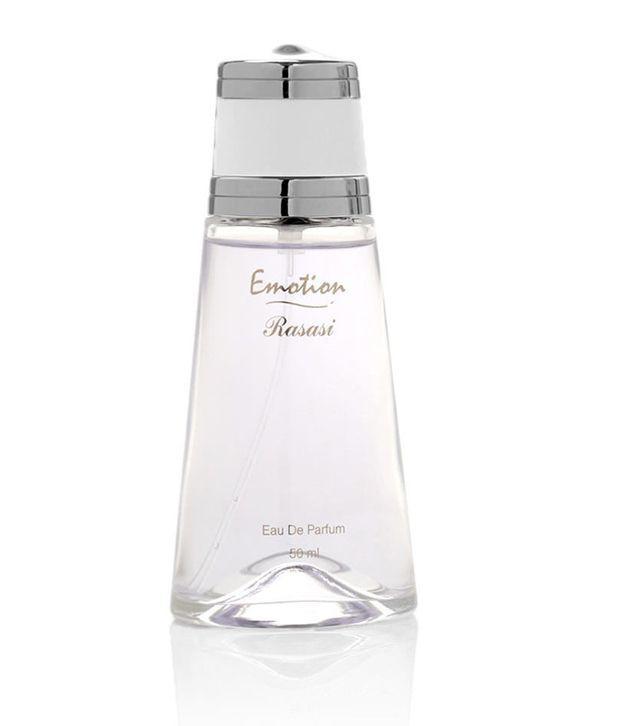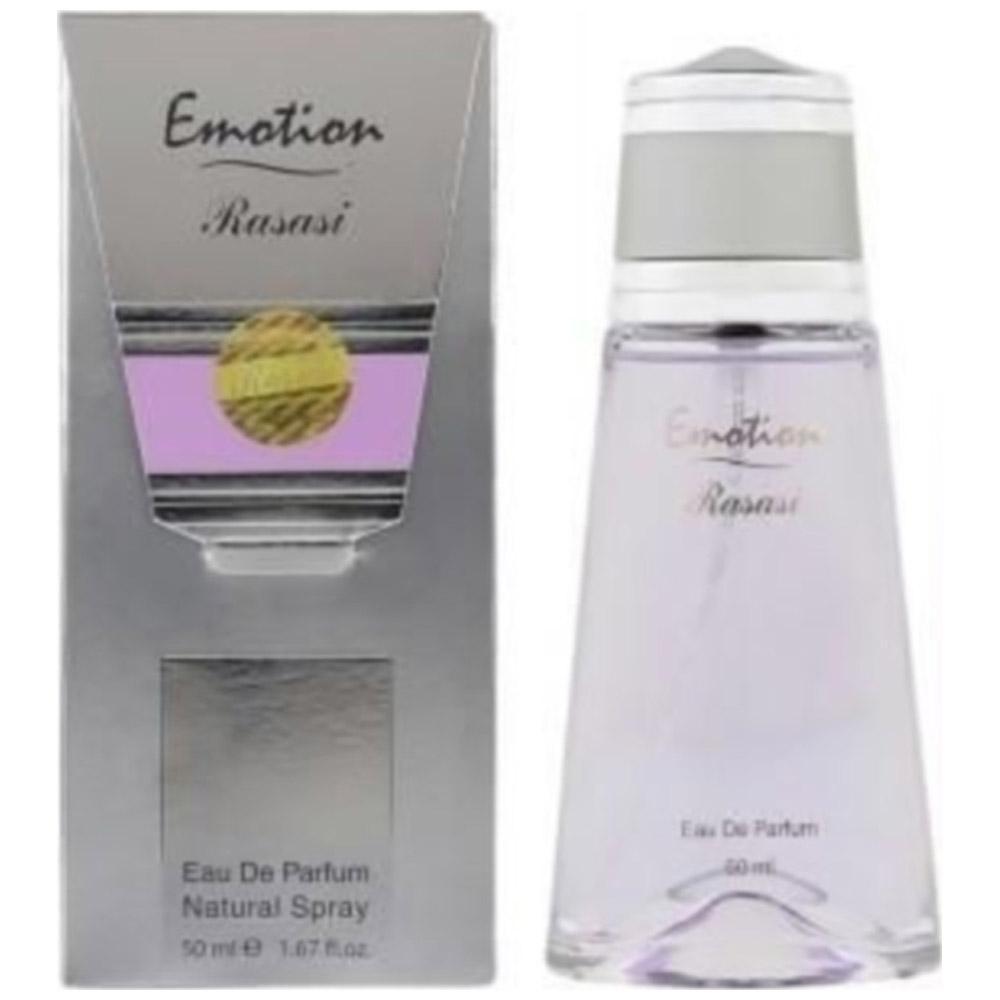The first image is the image on the left, the second image is the image on the right. Assess this claim about the two images: "There is a bottle of perfume without a box next to it.". Correct or not? Answer yes or no. Yes. 